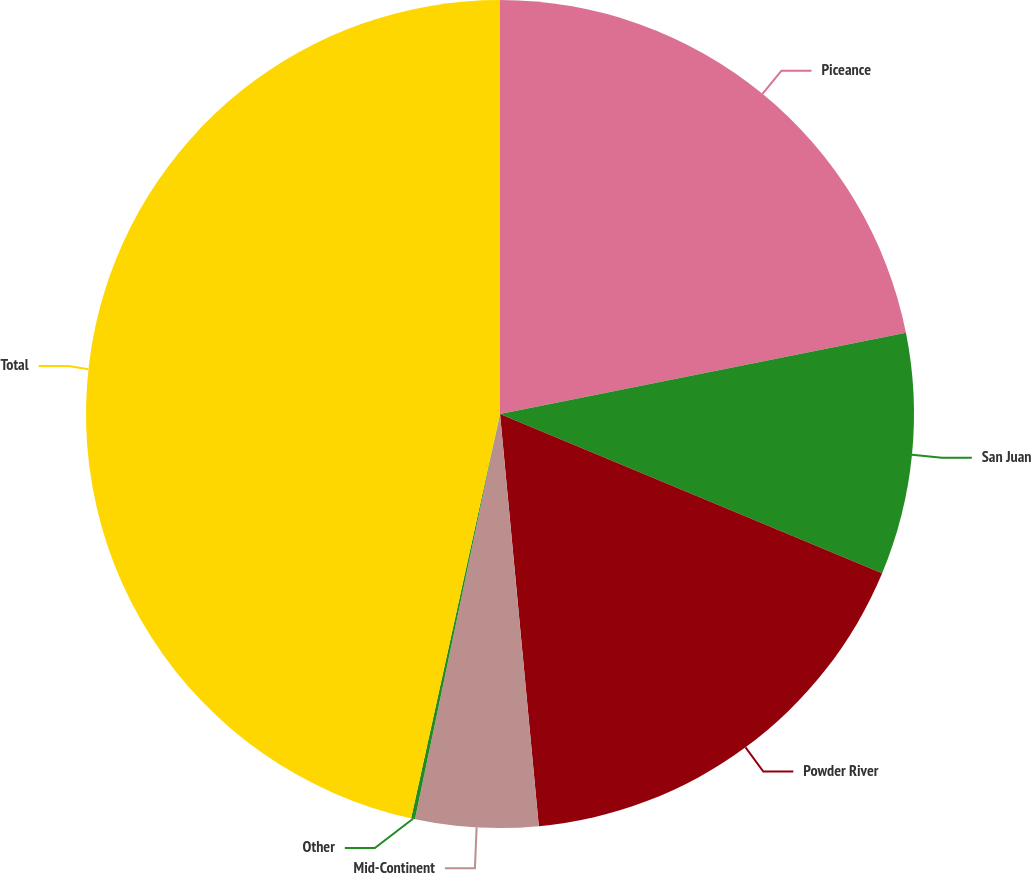Convert chart to OTSL. <chart><loc_0><loc_0><loc_500><loc_500><pie_chart><fcel>Piceance<fcel>San Juan<fcel>Powder River<fcel>Mid-Continent<fcel>Other<fcel>Total<nl><fcel>21.86%<fcel>9.43%<fcel>17.22%<fcel>4.79%<fcel>0.15%<fcel>46.56%<nl></chart> 